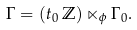Convert formula to latex. <formula><loc_0><loc_0><loc_500><loc_500>\Gamma = ( t _ { 0 } \, \mathbb { Z } ) \ltimes _ { \phi } \Gamma _ { 0 } .</formula> 